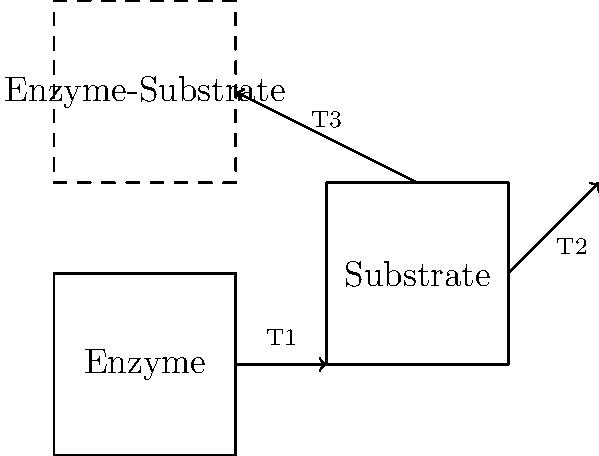In a model of enzyme-substrate interactions, three successive transformations (T1, T2, and T3) are applied to represent the binding process. T1 is a translation, T2 is a 45° rotation, and T3 is a reflection. If the initial position of the substrate is given by the coordinates (3,1), (5,1), (5,3), and (3,3), what is the final position of the top-left vertex of the substrate after all transformations are applied? Express your answer as an ordered pair (x,y) rounded to two decimal places. Let's approach this step-by-step:

1) Initial position of the top-left vertex: (3,3)

2) T1: Translation
   Assume the translation is 2 units right and 1 unit up.
   New position: (5,4)

3) T2: 45° Rotation
   To rotate a point (x,y) by θ degrees counterclockwise about the origin:
   x' = x cos θ - y sin θ
   y' = x sin θ + y cos θ
   
   For 45°, cos 45° = sin 45° = $\frac{1}{\sqrt{2}} \approx 0.7071$
   
   x' = 5(0.7071) - 4(0.7071) = 0.7071
   y' = 5(0.7071) + 4(0.7071) = 6.3639
   
   New position: (0.7071, 6.3639)

4) T3: Reflection
   Assume reflection is across the y-axis.
   New position: (-0.7071, 6.3639)

5) Rounding to two decimal places:
   Final position: (-0.71, 6.36)
Answer: (-0.71, 6.36) 